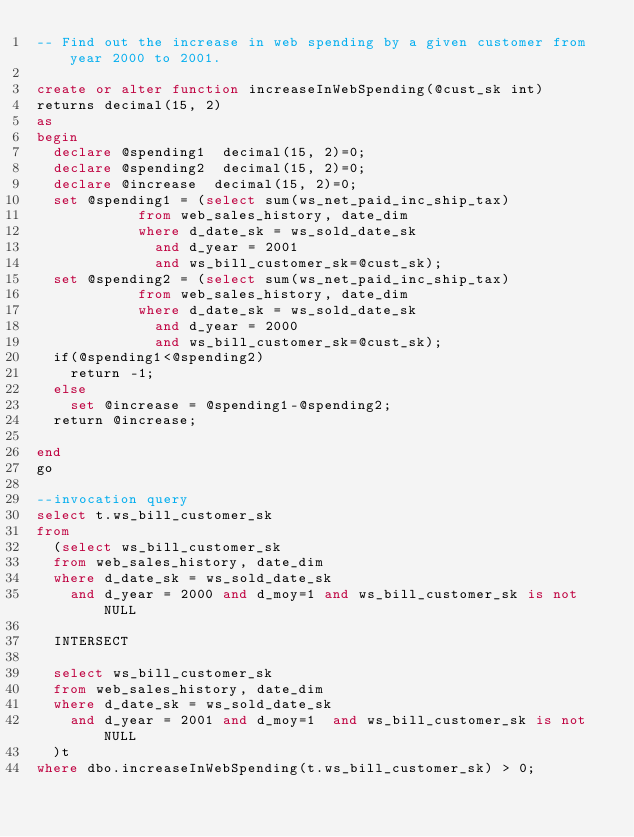Convert code to text. <code><loc_0><loc_0><loc_500><loc_500><_SQL_>-- Find out the increase in web spending by a given customer from year 2000 to 2001. 

create or alter function increaseInWebSpending(@cust_sk int)
returns decimal(15, 2)
as
begin
	declare @spending1  decimal(15, 2)=0;
	declare @spending2  decimal(15, 2)=0;
	declare @increase  decimal(15, 2)=0;
	set @spending1 = (select sum(ws_net_paid_inc_ship_tax) 
						from web_sales_history, date_dim
						where d_date_sk = ws_sold_date_sk
							and d_year = 2001
							and ws_bill_customer_sk=@cust_sk);
	set @spending2 = (select sum(ws_net_paid_inc_ship_tax) 
						from web_sales_history, date_dim
						where d_date_sk = ws_sold_date_sk
							and d_year = 2000
							and ws_bill_customer_sk=@cust_sk);
	if(@spending1<@spending2)
		return -1;
	else
		set @increase = @spending1-@spending2;
	return @increase;

end
go

--invocation query
select t.ws_bill_customer_sk
from 
	(select ws_bill_customer_sk
	from web_sales_history, date_dim
	where d_date_sk = ws_sold_date_sk
		and d_year = 2000 and d_moy=1 and ws_bill_customer_sk is not NULL

	INTERSECT

	select ws_bill_customer_sk
	from web_sales_history, date_dim
	where d_date_sk = ws_sold_date_sk
		and d_year = 2001 and d_moy=1  and ws_bill_customer_sk is not NULL
	)t
where dbo.increaseInWebSpending(t.ws_bill_customer_sk) > 0;
</code> 